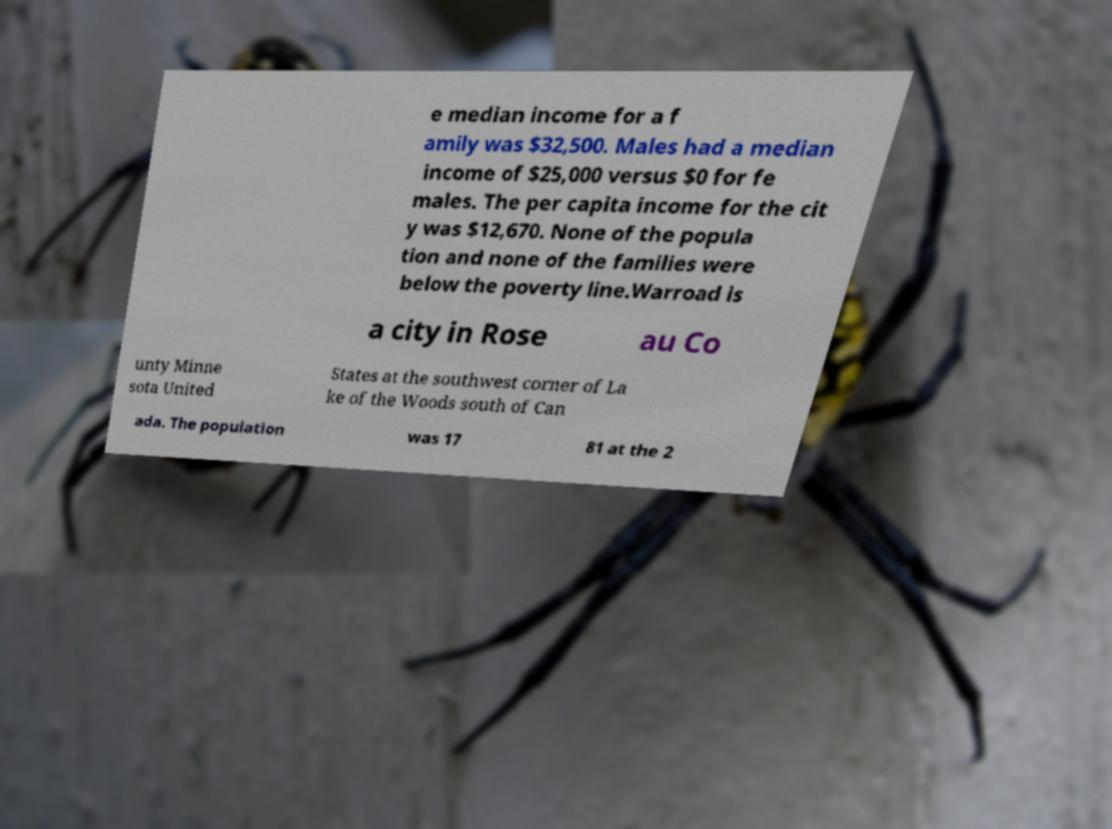Could you extract and type out the text from this image? e median income for a f amily was $32,500. Males had a median income of $25,000 versus $0 for fe males. The per capita income for the cit y was $12,670. None of the popula tion and none of the families were below the poverty line.Warroad is a city in Rose au Co unty Minne sota United States at the southwest corner of La ke of the Woods south of Can ada. The population was 17 81 at the 2 